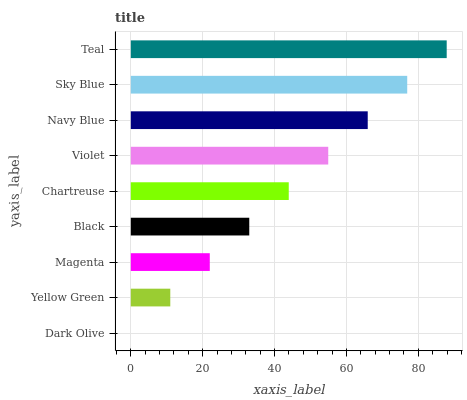Is Dark Olive the minimum?
Answer yes or no. Yes. Is Teal the maximum?
Answer yes or no. Yes. Is Yellow Green the minimum?
Answer yes or no. No. Is Yellow Green the maximum?
Answer yes or no. No. Is Yellow Green greater than Dark Olive?
Answer yes or no. Yes. Is Dark Olive less than Yellow Green?
Answer yes or no. Yes. Is Dark Olive greater than Yellow Green?
Answer yes or no. No. Is Yellow Green less than Dark Olive?
Answer yes or no. No. Is Chartreuse the high median?
Answer yes or no. Yes. Is Chartreuse the low median?
Answer yes or no. Yes. Is Violet the high median?
Answer yes or no. No. Is Magenta the low median?
Answer yes or no. No. 